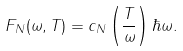<formula> <loc_0><loc_0><loc_500><loc_500>F _ { N } ( \omega , T ) = c _ { N } \left ( \frac { T } { \omega } \right ) \hbar { \omega } .</formula> 